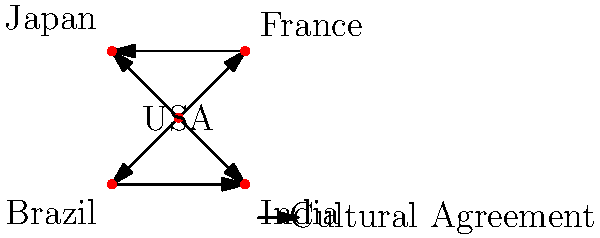Based on the network diagram of cultural agreements between countries, which nation appears to be the most influential in terms of cultural diplomacy, and what strategy might you recommend to further strengthen its position? To answer this question, let's analyze the network diagram step-by-step:

1. Identify the nodes: The diagram shows five countries - USA, France, Japan, Brazil, and India.

2. Count the connections:
   - USA: 4 connections (to all other countries)
   - France: 2 connections (to USA and Japan)
   - Japan: 3 connections (to USA, France, and India)
   - Brazil: 2 connections (to USA and India)
   - India: 3 connections (to USA, Japan, and Brazil)

3. Interpret the connections: Each arrow represents a cultural agreement between two countries.

4. Determine the most influential nation: The USA has the most connections (4), indicating it has cultural agreements with all other countries in the network. This suggests that the USA is the most influential in terms of cultural diplomacy.

5. Strategy to strengthen position:
   a) Deepen existing relationships by expanding the scope of current cultural agreements.
   b) Encourage multilateral cultural initiatives involving multiple partners.
   c) Focus on unique aspects of American culture that can be shared globally.
   d) Invest in educational and artistic exchange programs.
   e) Leverage digital platforms to reach wider audiences and promote cultural understanding.

By implementing these strategies, the USA can further solidify its position as a leader in cultural diplomacy, fostering stronger international relationships and mutual understanding.
Answer: USA; deepen existing agreements, promote multilateral initiatives, focus on unique cultural aspects, invest in exchanges, and leverage digital platforms. 